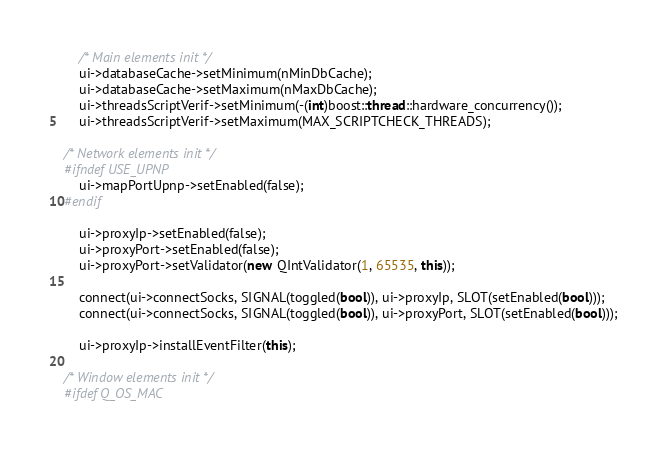Convert code to text. <code><loc_0><loc_0><loc_500><loc_500><_C++_>
    /* Main elements init */
    ui->databaseCache->setMinimum(nMinDbCache);
    ui->databaseCache->setMaximum(nMaxDbCache);
    ui->threadsScriptVerif->setMinimum(-(int)boost::thread::hardware_concurrency());
    ui->threadsScriptVerif->setMaximum(MAX_SCRIPTCHECK_THREADS);

/* Network elements init */
#ifndef USE_UPNP
    ui->mapPortUpnp->setEnabled(false);
#endif

    ui->proxyIp->setEnabled(false);
    ui->proxyPort->setEnabled(false);
    ui->proxyPort->setValidator(new QIntValidator(1, 65535, this));

    connect(ui->connectSocks, SIGNAL(toggled(bool)), ui->proxyIp, SLOT(setEnabled(bool)));
    connect(ui->connectSocks, SIGNAL(toggled(bool)), ui->proxyPort, SLOT(setEnabled(bool)));

    ui->proxyIp->installEventFilter(this);

/* Window elements init */
#ifdef Q_OS_MAC</code> 